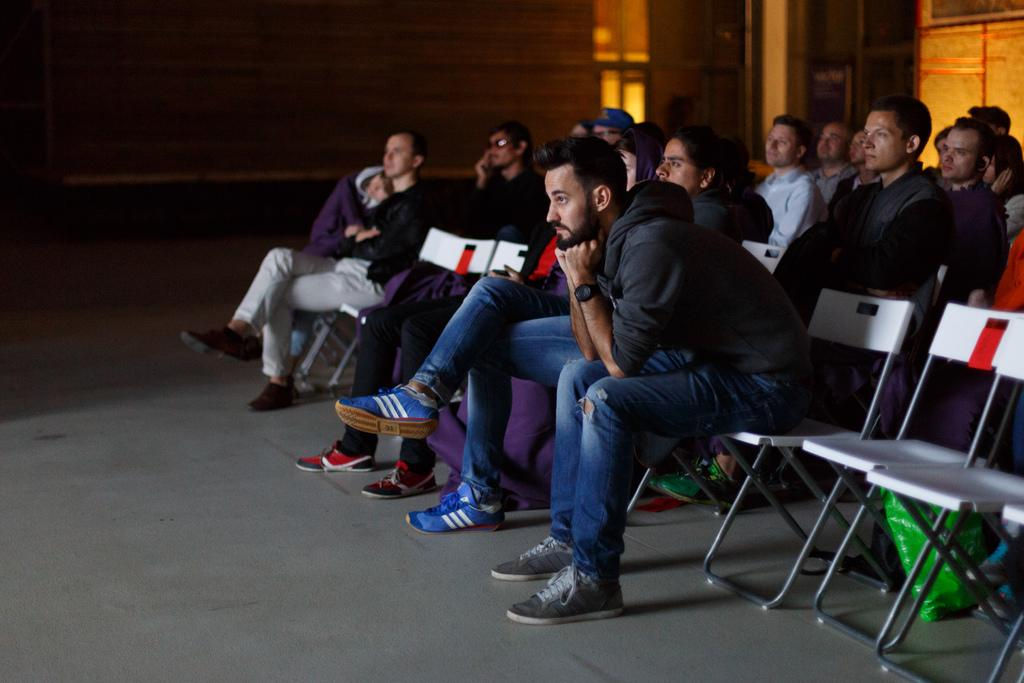What is the main subject of the image? The main subject of the image is a group of people. What are the people in the image doing? The people are sitting on chairs in the image. What can be seen on the surface in the image? There is a cover placed on a surface in the image. What is visible on the wall in the image? There is a wall with windows visible in the image. What type of land can be seen through the windows in the image? There is no land visible through the windows in the image; only the wall with windows is present. What statement is being made by the people in the image? There is no statement being made by the people in the image, as they are simply sitting on chairs. 